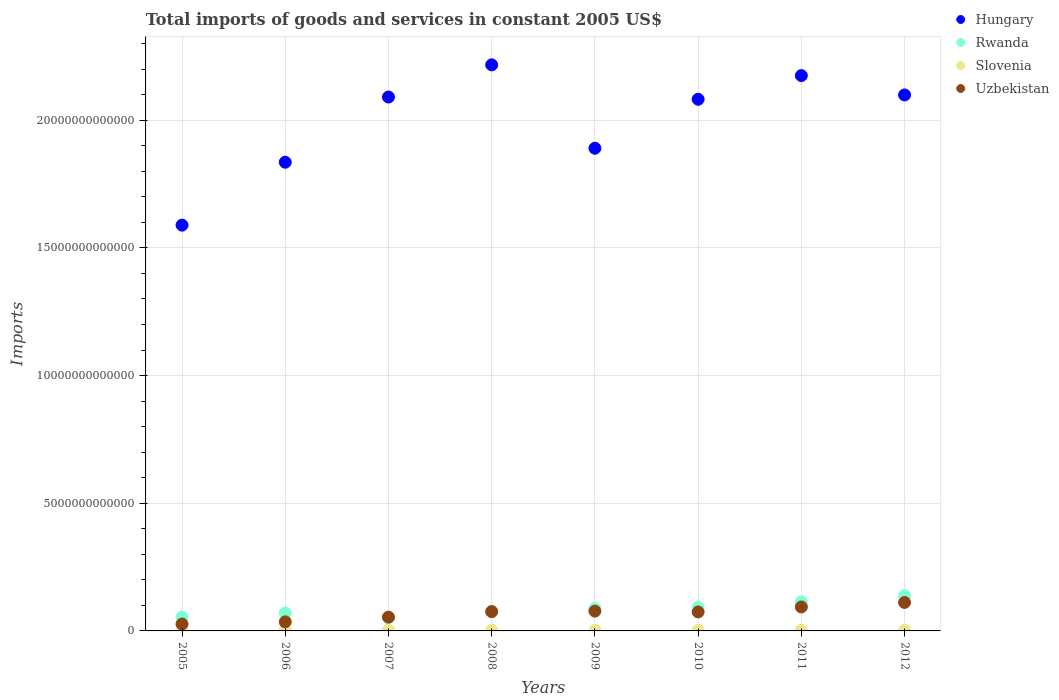What is the total imports of goods and services in Slovenia in 2006?
Give a very brief answer. 2.17e+1. Across all years, what is the maximum total imports of goods and services in Slovenia?
Your response must be concise. 2.63e+1. Across all years, what is the minimum total imports of goods and services in Rwanda?
Provide a short and direct response. 5.21e+11. In which year was the total imports of goods and services in Slovenia maximum?
Ensure brevity in your answer.  2008. In which year was the total imports of goods and services in Rwanda minimum?
Provide a short and direct response. 2007. What is the total total imports of goods and services in Slovenia in the graph?
Make the answer very short. 1.84e+11. What is the difference between the total imports of goods and services in Hungary in 2007 and that in 2011?
Your response must be concise. -8.39e+11. What is the difference between the total imports of goods and services in Hungary in 2006 and the total imports of goods and services in Rwanda in 2012?
Your answer should be very brief. 1.70e+13. What is the average total imports of goods and services in Rwanda per year?
Your answer should be very brief. 8.57e+11. In the year 2008, what is the difference between the total imports of goods and services in Hungary and total imports of goods and services in Slovenia?
Keep it short and to the point. 2.21e+13. What is the ratio of the total imports of goods and services in Hungary in 2009 to that in 2011?
Your response must be concise. 0.87. Is the total imports of goods and services in Uzbekistan in 2005 less than that in 2011?
Keep it short and to the point. Yes. What is the difference between the highest and the second highest total imports of goods and services in Rwanda?
Provide a succinct answer. 2.43e+11. What is the difference between the highest and the lowest total imports of goods and services in Rwanda?
Offer a terse response. 8.61e+11. In how many years, is the total imports of goods and services in Slovenia greater than the average total imports of goods and services in Slovenia taken over all years?
Provide a succinct answer. 4. Is the sum of the total imports of goods and services in Rwanda in 2006 and 2009 greater than the maximum total imports of goods and services in Hungary across all years?
Provide a succinct answer. No. Does the total imports of goods and services in Hungary monotonically increase over the years?
Provide a short and direct response. No. How many dotlines are there?
Offer a terse response. 4. What is the difference between two consecutive major ticks on the Y-axis?
Your answer should be compact. 5.00e+12. Where does the legend appear in the graph?
Your response must be concise. Top right. What is the title of the graph?
Ensure brevity in your answer.  Total imports of goods and services in constant 2005 US$. What is the label or title of the Y-axis?
Provide a succinct answer. Imports. What is the Imports in Hungary in 2005?
Give a very brief answer. 1.59e+13. What is the Imports of Rwanda in 2005?
Offer a very short reply. 5.43e+11. What is the Imports in Slovenia in 2005?
Your response must be concise. 1.93e+1. What is the Imports in Uzbekistan in 2005?
Ensure brevity in your answer.  2.72e+11. What is the Imports of Hungary in 2006?
Keep it short and to the point. 1.84e+13. What is the Imports of Rwanda in 2006?
Your answer should be compact. 7.03e+11. What is the Imports in Slovenia in 2006?
Provide a succinct answer. 2.17e+1. What is the Imports in Uzbekistan in 2006?
Offer a terse response. 3.55e+11. What is the Imports in Hungary in 2007?
Keep it short and to the point. 2.09e+13. What is the Imports of Rwanda in 2007?
Offer a terse response. 5.21e+11. What is the Imports in Slovenia in 2007?
Keep it short and to the point. 2.53e+1. What is the Imports in Uzbekistan in 2007?
Your response must be concise. 5.40e+11. What is the Imports in Hungary in 2008?
Provide a short and direct response. 2.22e+13. What is the Imports in Rwanda in 2008?
Provide a succinct answer. 7.78e+11. What is the Imports in Slovenia in 2008?
Keep it short and to the point. 2.63e+1. What is the Imports in Uzbekistan in 2008?
Your response must be concise. 7.55e+11. What is the Imports of Hungary in 2009?
Your response must be concise. 1.89e+13. What is the Imports in Rwanda in 2009?
Your answer should be compact. 8.77e+11. What is the Imports in Slovenia in 2009?
Provide a succinct answer. 2.13e+1. What is the Imports in Uzbekistan in 2009?
Your answer should be very brief. 7.75e+11. What is the Imports of Hungary in 2010?
Ensure brevity in your answer.  2.08e+13. What is the Imports of Rwanda in 2010?
Offer a terse response. 9.15e+11. What is the Imports of Slovenia in 2010?
Your answer should be very brief. 2.28e+1. What is the Imports in Uzbekistan in 2010?
Provide a short and direct response. 7.43e+11. What is the Imports of Hungary in 2011?
Offer a terse response. 2.17e+13. What is the Imports of Rwanda in 2011?
Your response must be concise. 1.14e+12. What is the Imports of Slovenia in 2011?
Provide a succinct answer. 2.39e+1. What is the Imports of Uzbekistan in 2011?
Give a very brief answer. 9.39e+11. What is the Imports of Hungary in 2012?
Make the answer very short. 2.10e+13. What is the Imports in Rwanda in 2012?
Your answer should be very brief. 1.38e+12. What is the Imports in Slovenia in 2012?
Your response must be concise. 2.30e+1. What is the Imports of Uzbekistan in 2012?
Your answer should be very brief. 1.12e+12. Across all years, what is the maximum Imports of Hungary?
Make the answer very short. 2.22e+13. Across all years, what is the maximum Imports of Rwanda?
Your answer should be compact. 1.38e+12. Across all years, what is the maximum Imports in Slovenia?
Your answer should be very brief. 2.63e+1. Across all years, what is the maximum Imports of Uzbekistan?
Make the answer very short. 1.12e+12. Across all years, what is the minimum Imports of Hungary?
Offer a terse response. 1.59e+13. Across all years, what is the minimum Imports of Rwanda?
Make the answer very short. 5.21e+11. Across all years, what is the minimum Imports in Slovenia?
Your response must be concise. 1.93e+1. Across all years, what is the minimum Imports in Uzbekistan?
Offer a terse response. 2.72e+11. What is the total Imports of Hungary in the graph?
Your response must be concise. 1.60e+14. What is the total Imports in Rwanda in the graph?
Your answer should be compact. 6.86e+12. What is the total Imports of Slovenia in the graph?
Make the answer very short. 1.84e+11. What is the total Imports of Uzbekistan in the graph?
Provide a short and direct response. 5.49e+12. What is the difference between the Imports of Hungary in 2005 and that in 2006?
Offer a terse response. -2.46e+12. What is the difference between the Imports in Rwanda in 2005 and that in 2006?
Offer a very short reply. -1.60e+11. What is the difference between the Imports of Slovenia in 2005 and that in 2006?
Offer a very short reply. -2.39e+09. What is the difference between the Imports in Uzbekistan in 2005 and that in 2006?
Ensure brevity in your answer.  -8.37e+1. What is the difference between the Imports in Hungary in 2005 and that in 2007?
Your answer should be compact. -5.02e+12. What is the difference between the Imports of Rwanda in 2005 and that in 2007?
Offer a very short reply. 2.20e+1. What is the difference between the Imports in Slovenia in 2005 and that in 2007?
Provide a short and direct response. -6.02e+09. What is the difference between the Imports in Uzbekistan in 2005 and that in 2007?
Ensure brevity in your answer.  -2.68e+11. What is the difference between the Imports of Hungary in 2005 and that in 2008?
Your response must be concise. -6.28e+12. What is the difference between the Imports in Rwanda in 2005 and that in 2008?
Provide a succinct answer. -2.35e+11. What is the difference between the Imports in Slovenia in 2005 and that in 2008?
Offer a very short reply. -7.00e+09. What is the difference between the Imports of Uzbekistan in 2005 and that in 2008?
Offer a terse response. -4.83e+11. What is the difference between the Imports in Hungary in 2005 and that in 2009?
Ensure brevity in your answer.  -3.01e+12. What is the difference between the Imports of Rwanda in 2005 and that in 2009?
Ensure brevity in your answer.  -3.34e+11. What is the difference between the Imports in Slovenia in 2005 and that in 2009?
Make the answer very short. -2.04e+09. What is the difference between the Imports of Uzbekistan in 2005 and that in 2009?
Offer a terse response. -5.03e+11. What is the difference between the Imports in Hungary in 2005 and that in 2010?
Give a very brief answer. -4.93e+12. What is the difference between the Imports of Rwanda in 2005 and that in 2010?
Offer a terse response. -3.72e+11. What is the difference between the Imports in Slovenia in 2005 and that in 2010?
Keep it short and to the point. -3.50e+09. What is the difference between the Imports in Uzbekistan in 2005 and that in 2010?
Give a very brief answer. -4.71e+11. What is the difference between the Imports in Hungary in 2005 and that in 2011?
Provide a succinct answer. -5.86e+12. What is the difference between the Imports of Rwanda in 2005 and that in 2011?
Offer a terse response. -5.96e+11. What is the difference between the Imports of Slovenia in 2005 and that in 2011?
Your answer should be compact. -4.64e+09. What is the difference between the Imports of Uzbekistan in 2005 and that in 2011?
Provide a short and direct response. -6.67e+11. What is the difference between the Imports in Hungary in 2005 and that in 2012?
Keep it short and to the point. -5.10e+12. What is the difference between the Imports of Rwanda in 2005 and that in 2012?
Provide a succinct answer. -8.39e+11. What is the difference between the Imports in Slovenia in 2005 and that in 2012?
Keep it short and to the point. -3.75e+09. What is the difference between the Imports of Uzbekistan in 2005 and that in 2012?
Ensure brevity in your answer.  -8.44e+11. What is the difference between the Imports in Hungary in 2006 and that in 2007?
Your answer should be very brief. -2.55e+12. What is the difference between the Imports of Rwanda in 2006 and that in 2007?
Keep it short and to the point. 1.82e+11. What is the difference between the Imports in Slovenia in 2006 and that in 2007?
Make the answer very short. -3.63e+09. What is the difference between the Imports in Uzbekistan in 2006 and that in 2007?
Make the answer very short. -1.85e+11. What is the difference between the Imports in Hungary in 2006 and that in 2008?
Provide a succinct answer. -3.81e+12. What is the difference between the Imports of Rwanda in 2006 and that in 2008?
Give a very brief answer. -7.50e+1. What is the difference between the Imports of Slovenia in 2006 and that in 2008?
Ensure brevity in your answer.  -4.61e+09. What is the difference between the Imports of Uzbekistan in 2006 and that in 2008?
Offer a very short reply. -3.99e+11. What is the difference between the Imports in Hungary in 2006 and that in 2009?
Your answer should be very brief. -5.47e+11. What is the difference between the Imports in Rwanda in 2006 and that in 2009?
Provide a succinct answer. -1.74e+11. What is the difference between the Imports of Slovenia in 2006 and that in 2009?
Provide a succinct answer. 3.45e+08. What is the difference between the Imports in Uzbekistan in 2006 and that in 2009?
Give a very brief answer. -4.20e+11. What is the difference between the Imports in Hungary in 2006 and that in 2010?
Ensure brevity in your answer.  -2.46e+12. What is the difference between the Imports of Rwanda in 2006 and that in 2010?
Make the answer very short. -2.12e+11. What is the difference between the Imports in Slovenia in 2006 and that in 2010?
Ensure brevity in your answer.  -1.11e+09. What is the difference between the Imports in Uzbekistan in 2006 and that in 2010?
Your response must be concise. -3.88e+11. What is the difference between the Imports in Hungary in 2006 and that in 2011?
Offer a terse response. -3.39e+12. What is the difference between the Imports of Rwanda in 2006 and that in 2011?
Ensure brevity in your answer.  -4.36e+11. What is the difference between the Imports in Slovenia in 2006 and that in 2011?
Your answer should be very brief. -2.25e+09. What is the difference between the Imports in Uzbekistan in 2006 and that in 2011?
Your response must be concise. -5.83e+11. What is the difference between the Imports in Hungary in 2006 and that in 2012?
Offer a very short reply. -2.63e+12. What is the difference between the Imports in Rwanda in 2006 and that in 2012?
Provide a succinct answer. -6.79e+11. What is the difference between the Imports of Slovenia in 2006 and that in 2012?
Make the answer very short. -1.37e+09. What is the difference between the Imports in Uzbekistan in 2006 and that in 2012?
Your response must be concise. -7.60e+11. What is the difference between the Imports in Hungary in 2007 and that in 2008?
Your answer should be very brief. -1.26e+12. What is the difference between the Imports of Rwanda in 2007 and that in 2008?
Provide a short and direct response. -2.57e+11. What is the difference between the Imports in Slovenia in 2007 and that in 2008?
Make the answer very short. -9.74e+08. What is the difference between the Imports in Uzbekistan in 2007 and that in 2008?
Your answer should be very brief. -2.15e+11. What is the difference between the Imports in Hungary in 2007 and that in 2009?
Provide a succinct answer. 2.01e+12. What is the difference between the Imports of Rwanda in 2007 and that in 2009?
Ensure brevity in your answer.  -3.56e+11. What is the difference between the Imports in Slovenia in 2007 and that in 2009?
Ensure brevity in your answer.  3.98e+09. What is the difference between the Imports in Uzbekistan in 2007 and that in 2009?
Your answer should be very brief. -2.35e+11. What is the difference between the Imports in Hungary in 2007 and that in 2010?
Provide a short and direct response. 8.74e+1. What is the difference between the Imports of Rwanda in 2007 and that in 2010?
Provide a short and direct response. -3.94e+11. What is the difference between the Imports in Slovenia in 2007 and that in 2010?
Ensure brevity in your answer.  2.52e+09. What is the difference between the Imports in Uzbekistan in 2007 and that in 2010?
Offer a terse response. -2.03e+11. What is the difference between the Imports in Hungary in 2007 and that in 2011?
Your answer should be very brief. -8.39e+11. What is the difference between the Imports in Rwanda in 2007 and that in 2011?
Provide a short and direct response. -6.18e+11. What is the difference between the Imports of Slovenia in 2007 and that in 2011?
Your response must be concise. 1.38e+09. What is the difference between the Imports of Uzbekistan in 2007 and that in 2011?
Provide a short and direct response. -3.99e+11. What is the difference between the Imports in Hungary in 2007 and that in 2012?
Your response must be concise. -8.21e+1. What is the difference between the Imports of Rwanda in 2007 and that in 2012?
Keep it short and to the point. -8.61e+11. What is the difference between the Imports in Slovenia in 2007 and that in 2012?
Offer a very short reply. 2.27e+09. What is the difference between the Imports in Uzbekistan in 2007 and that in 2012?
Make the answer very short. -5.75e+11. What is the difference between the Imports in Hungary in 2008 and that in 2009?
Offer a very short reply. 3.27e+12. What is the difference between the Imports in Rwanda in 2008 and that in 2009?
Give a very brief answer. -9.90e+1. What is the difference between the Imports in Slovenia in 2008 and that in 2009?
Provide a short and direct response. 4.95e+09. What is the difference between the Imports in Uzbekistan in 2008 and that in 2009?
Your answer should be very brief. -2.02e+1. What is the difference between the Imports in Hungary in 2008 and that in 2010?
Your response must be concise. 1.35e+12. What is the difference between the Imports in Rwanda in 2008 and that in 2010?
Offer a terse response. -1.37e+11. What is the difference between the Imports in Slovenia in 2008 and that in 2010?
Provide a short and direct response. 3.49e+09. What is the difference between the Imports of Uzbekistan in 2008 and that in 2010?
Keep it short and to the point. 1.18e+1. What is the difference between the Imports in Hungary in 2008 and that in 2011?
Give a very brief answer. 4.21e+11. What is the difference between the Imports of Rwanda in 2008 and that in 2011?
Your answer should be compact. -3.61e+11. What is the difference between the Imports in Slovenia in 2008 and that in 2011?
Give a very brief answer. 2.35e+09. What is the difference between the Imports of Uzbekistan in 2008 and that in 2011?
Provide a short and direct response. -1.84e+11. What is the difference between the Imports of Hungary in 2008 and that in 2012?
Your answer should be compact. 1.18e+12. What is the difference between the Imports of Rwanda in 2008 and that in 2012?
Give a very brief answer. -6.04e+11. What is the difference between the Imports of Slovenia in 2008 and that in 2012?
Offer a very short reply. 3.24e+09. What is the difference between the Imports of Uzbekistan in 2008 and that in 2012?
Ensure brevity in your answer.  -3.60e+11. What is the difference between the Imports of Hungary in 2009 and that in 2010?
Your answer should be very brief. -1.92e+12. What is the difference between the Imports in Rwanda in 2009 and that in 2010?
Offer a terse response. -3.80e+1. What is the difference between the Imports of Slovenia in 2009 and that in 2010?
Provide a short and direct response. -1.46e+09. What is the difference between the Imports of Uzbekistan in 2009 and that in 2010?
Give a very brief answer. 3.20e+1. What is the difference between the Imports in Hungary in 2009 and that in 2011?
Provide a short and direct response. -2.84e+12. What is the difference between the Imports of Rwanda in 2009 and that in 2011?
Make the answer very short. -2.62e+11. What is the difference between the Imports of Slovenia in 2009 and that in 2011?
Offer a terse response. -2.60e+09. What is the difference between the Imports of Uzbekistan in 2009 and that in 2011?
Offer a terse response. -1.64e+11. What is the difference between the Imports of Hungary in 2009 and that in 2012?
Make the answer very short. -2.09e+12. What is the difference between the Imports of Rwanda in 2009 and that in 2012?
Ensure brevity in your answer.  -5.05e+11. What is the difference between the Imports in Slovenia in 2009 and that in 2012?
Ensure brevity in your answer.  -1.71e+09. What is the difference between the Imports of Uzbekistan in 2009 and that in 2012?
Offer a terse response. -3.40e+11. What is the difference between the Imports of Hungary in 2010 and that in 2011?
Keep it short and to the point. -9.27e+11. What is the difference between the Imports in Rwanda in 2010 and that in 2011?
Keep it short and to the point. -2.24e+11. What is the difference between the Imports in Slovenia in 2010 and that in 2011?
Provide a short and direct response. -1.14e+09. What is the difference between the Imports of Uzbekistan in 2010 and that in 2011?
Offer a terse response. -1.96e+11. What is the difference between the Imports in Hungary in 2010 and that in 2012?
Offer a very short reply. -1.69e+11. What is the difference between the Imports in Rwanda in 2010 and that in 2012?
Offer a very short reply. -4.67e+11. What is the difference between the Imports of Slovenia in 2010 and that in 2012?
Give a very brief answer. -2.52e+08. What is the difference between the Imports of Uzbekistan in 2010 and that in 2012?
Your response must be concise. -3.72e+11. What is the difference between the Imports of Hungary in 2011 and that in 2012?
Your answer should be very brief. 7.57e+11. What is the difference between the Imports in Rwanda in 2011 and that in 2012?
Ensure brevity in your answer.  -2.43e+11. What is the difference between the Imports of Slovenia in 2011 and that in 2012?
Give a very brief answer. 8.86e+08. What is the difference between the Imports of Uzbekistan in 2011 and that in 2012?
Give a very brief answer. -1.77e+11. What is the difference between the Imports in Hungary in 2005 and the Imports in Rwanda in 2006?
Offer a very short reply. 1.52e+13. What is the difference between the Imports of Hungary in 2005 and the Imports of Slovenia in 2006?
Your response must be concise. 1.59e+13. What is the difference between the Imports of Hungary in 2005 and the Imports of Uzbekistan in 2006?
Provide a short and direct response. 1.55e+13. What is the difference between the Imports in Rwanda in 2005 and the Imports in Slovenia in 2006?
Provide a succinct answer. 5.21e+11. What is the difference between the Imports in Rwanda in 2005 and the Imports in Uzbekistan in 2006?
Provide a succinct answer. 1.88e+11. What is the difference between the Imports in Slovenia in 2005 and the Imports in Uzbekistan in 2006?
Ensure brevity in your answer.  -3.36e+11. What is the difference between the Imports in Hungary in 2005 and the Imports in Rwanda in 2007?
Keep it short and to the point. 1.54e+13. What is the difference between the Imports of Hungary in 2005 and the Imports of Slovenia in 2007?
Make the answer very short. 1.59e+13. What is the difference between the Imports of Hungary in 2005 and the Imports of Uzbekistan in 2007?
Make the answer very short. 1.53e+13. What is the difference between the Imports in Rwanda in 2005 and the Imports in Slovenia in 2007?
Give a very brief answer. 5.18e+11. What is the difference between the Imports of Rwanda in 2005 and the Imports of Uzbekistan in 2007?
Your response must be concise. 3.06e+09. What is the difference between the Imports in Slovenia in 2005 and the Imports in Uzbekistan in 2007?
Offer a terse response. -5.21e+11. What is the difference between the Imports of Hungary in 2005 and the Imports of Rwanda in 2008?
Offer a very short reply. 1.51e+13. What is the difference between the Imports of Hungary in 2005 and the Imports of Slovenia in 2008?
Offer a very short reply. 1.59e+13. What is the difference between the Imports in Hungary in 2005 and the Imports in Uzbekistan in 2008?
Provide a succinct answer. 1.51e+13. What is the difference between the Imports of Rwanda in 2005 and the Imports of Slovenia in 2008?
Your answer should be compact. 5.17e+11. What is the difference between the Imports in Rwanda in 2005 and the Imports in Uzbekistan in 2008?
Keep it short and to the point. -2.12e+11. What is the difference between the Imports in Slovenia in 2005 and the Imports in Uzbekistan in 2008?
Provide a short and direct response. -7.36e+11. What is the difference between the Imports of Hungary in 2005 and the Imports of Rwanda in 2009?
Your response must be concise. 1.50e+13. What is the difference between the Imports of Hungary in 2005 and the Imports of Slovenia in 2009?
Your answer should be compact. 1.59e+13. What is the difference between the Imports in Hungary in 2005 and the Imports in Uzbekistan in 2009?
Your response must be concise. 1.51e+13. What is the difference between the Imports of Rwanda in 2005 and the Imports of Slovenia in 2009?
Provide a short and direct response. 5.22e+11. What is the difference between the Imports in Rwanda in 2005 and the Imports in Uzbekistan in 2009?
Ensure brevity in your answer.  -2.32e+11. What is the difference between the Imports in Slovenia in 2005 and the Imports in Uzbekistan in 2009?
Make the answer very short. -7.56e+11. What is the difference between the Imports of Hungary in 2005 and the Imports of Rwanda in 2010?
Offer a terse response. 1.50e+13. What is the difference between the Imports in Hungary in 2005 and the Imports in Slovenia in 2010?
Make the answer very short. 1.59e+13. What is the difference between the Imports of Hungary in 2005 and the Imports of Uzbekistan in 2010?
Give a very brief answer. 1.51e+13. What is the difference between the Imports in Rwanda in 2005 and the Imports in Slovenia in 2010?
Give a very brief answer. 5.20e+11. What is the difference between the Imports in Rwanda in 2005 and the Imports in Uzbekistan in 2010?
Provide a short and direct response. -2.00e+11. What is the difference between the Imports of Slovenia in 2005 and the Imports of Uzbekistan in 2010?
Offer a very short reply. -7.24e+11. What is the difference between the Imports in Hungary in 2005 and the Imports in Rwanda in 2011?
Your response must be concise. 1.48e+13. What is the difference between the Imports in Hungary in 2005 and the Imports in Slovenia in 2011?
Keep it short and to the point. 1.59e+13. What is the difference between the Imports of Hungary in 2005 and the Imports of Uzbekistan in 2011?
Give a very brief answer. 1.50e+13. What is the difference between the Imports of Rwanda in 2005 and the Imports of Slovenia in 2011?
Provide a succinct answer. 5.19e+11. What is the difference between the Imports in Rwanda in 2005 and the Imports in Uzbekistan in 2011?
Make the answer very short. -3.96e+11. What is the difference between the Imports in Slovenia in 2005 and the Imports in Uzbekistan in 2011?
Your answer should be very brief. -9.19e+11. What is the difference between the Imports of Hungary in 2005 and the Imports of Rwanda in 2012?
Give a very brief answer. 1.45e+13. What is the difference between the Imports of Hungary in 2005 and the Imports of Slovenia in 2012?
Keep it short and to the point. 1.59e+13. What is the difference between the Imports of Hungary in 2005 and the Imports of Uzbekistan in 2012?
Keep it short and to the point. 1.48e+13. What is the difference between the Imports of Rwanda in 2005 and the Imports of Slovenia in 2012?
Make the answer very short. 5.20e+11. What is the difference between the Imports of Rwanda in 2005 and the Imports of Uzbekistan in 2012?
Provide a short and direct response. -5.72e+11. What is the difference between the Imports in Slovenia in 2005 and the Imports in Uzbekistan in 2012?
Give a very brief answer. -1.10e+12. What is the difference between the Imports of Hungary in 2006 and the Imports of Rwanda in 2007?
Your answer should be very brief. 1.78e+13. What is the difference between the Imports of Hungary in 2006 and the Imports of Slovenia in 2007?
Provide a succinct answer. 1.83e+13. What is the difference between the Imports of Hungary in 2006 and the Imports of Uzbekistan in 2007?
Provide a short and direct response. 1.78e+13. What is the difference between the Imports of Rwanda in 2006 and the Imports of Slovenia in 2007?
Make the answer very short. 6.78e+11. What is the difference between the Imports of Rwanda in 2006 and the Imports of Uzbekistan in 2007?
Give a very brief answer. 1.63e+11. What is the difference between the Imports of Slovenia in 2006 and the Imports of Uzbekistan in 2007?
Your answer should be compact. -5.18e+11. What is the difference between the Imports in Hungary in 2006 and the Imports in Rwanda in 2008?
Provide a short and direct response. 1.76e+13. What is the difference between the Imports of Hungary in 2006 and the Imports of Slovenia in 2008?
Offer a terse response. 1.83e+13. What is the difference between the Imports in Hungary in 2006 and the Imports in Uzbekistan in 2008?
Give a very brief answer. 1.76e+13. What is the difference between the Imports in Rwanda in 2006 and the Imports in Slovenia in 2008?
Make the answer very short. 6.77e+11. What is the difference between the Imports of Rwanda in 2006 and the Imports of Uzbekistan in 2008?
Ensure brevity in your answer.  -5.18e+1. What is the difference between the Imports in Slovenia in 2006 and the Imports in Uzbekistan in 2008?
Offer a very short reply. -7.33e+11. What is the difference between the Imports of Hungary in 2006 and the Imports of Rwanda in 2009?
Your answer should be compact. 1.75e+13. What is the difference between the Imports in Hungary in 2006 and the Imports in Slovenia in 2009?
Your answer should be compact. 1.83e+13. What is the difference between the Imports in Hungary in 2006 and the Imports in Uzbekistan in 2009?
Ensure brevity in your answer.  1.76e+13. What is the difference between the Imports of Rwanda in 2006 and the Imports of Slovenia in 2009?
Your response must be concise. 6.82e+11. What is the difference between the Imports of Rwanda in 2006 and the Imports of Uzbekistan in 2009?
Your response must be concise. -7.20e+1. What is the difference between the Imports in Slovenia in 2006 and the Imports in Uzbekistan in 2009?
Your response must be concise. -7.53e+11. What is the difference between the Imports of Hungary in 2006 and the Imports of Rwanda in 2010?
Your answer should be very brief. 1.74e+13. What is the difference between the Imports of Hungary in 2006 and the Imports of Slovenia in 2010?
Your answer should be very brief. 1.83e+13. What is the difference between the Imports of Hungary in 2006 and the Imports of Uzbekistan in 2010?
Ensure brevity in your answer.  1.76e+13. What is the difference between the Imports of Rwanda in 2006 and the Imports of Slovenia in 2010?
Provide a succinct answer. 6.80e+11. What is the difference between the Imports of Rwanda in 2006 and the Imports of Uzbekistan in 2010?
Offer a very short reply. -4.00e+1. What is the difference between the Imports in Slovenia in 2006 and the Imports in Uzbekistan in 2010?
Offer a very short reply. -7.21e+11. What is the difference between the Imports in Hungary in 2006 and the Imports in Rwanda in 2011?
Your answer should be compact. 1.72e+13. What is the difference between the Imports in Hungary in 2006 and the Imports in Slovenia in 2011?
Your answer should be compact. 1.83e+13. What is the difference between the Imports of Hungary in 2006 and the Imports of Uzbekistan in 2011?
Your answer should be compact. 1.74e+13. What is the difference between the Imports of Rwanda in 2006 and the Imports of Slovenia in 2011?
Your answer should be compact. 6.79e+11. What is the difference between the Imports of Rwanda in 2006 and the Imports of Uzbekistan in 2011?
Your response must be concise. -2.36e+11. What is the difference between the Imports in Slovenia in 2006 and the Imports in Uzbekistan in 2011?
Your response must be concise. -9.17e+11. What is the difference between the Imports in Hungary in 2006 and the Imports in Rwanda in 2012?
Keep it short and to the point. 1.70e+13. What is the difference between the Imports in Hungary in 2006 and the Imports in Slovenia in 2012?
Your answer should be compact. 1.83e+13. What is the difference between the Imports in Hungary in 2006 and the Imports in Uzbekistan in 2012?
Provide a succinct answer. 1.72e+13. What is the difference between the Imports of Rwanda in 2006 and the Imports of Slovenia in 2012?
Give a very brief answer. 6.80e+11. What is the difference between the Imports of Rwanda in 2006 and the Imports of Uzbekistan in 2012?
Offer a very short reply. -4.12e+11. What is the difference between the Imports of Slovenia in 2006 and the Imports of Uzbekistan in 2012?
Keep it short and to the point. -1.09e+12. What is the difference between the Imports in Hungary in 2007 and the Imports in Rwanda in 2008?
Your answer should be very brief. 2.01e+13. What is the difference between the Imports of Hungary in 2007 and the Imports of Slovenia in 2008?
Provide a succinct answer. 2.09e+13. What is the difference between the Imports of Hungary in 2007 and the Imports of Uzbekistan in 2008?
Make the answer very short. 2.02e+13. What is the difference between the Imports of Rwanda in 2007 and the Imports of Slovenia in 2008?
Give a very brief answer. 4.95e+11. What is the difference between the Imports of Rwanda in 2007 and the Imports of Uzbekistan in 2008?
Offer a very short reply. -2.34e+11. What is the difference between the Imports in Slovenia in 2007 and the Imports in Uzbekistan in 2008?
Your answer should be very brief. -7.29e+11. What is the difference between the Imports of Hungary in 2007 and the Imports of Rwanda in 2009?
Offer a very short reply. 2.00e+13. What is the difference between the Imports in Hungary in 2007 and the Imports in Slovenia in 2009?
Keep it short and to the point. 2.09e+13. What is the difference between the Imports in Hungary in 2007 and the Imports in Uzbekistan in 2009?
Keep it short and to the point. 2.01e+13. What is the difference between the Imports of Rwanda in 2007 and the Imports of Slovenia in 2009?
Provide a succinct answer. 5.00e+11. What is the difference between the Imports of Rwanda in 2007 and the Imports of Uzbekistan in 2009?
Your response must be concise. -2.54e+11. What is the difference between the Imports of Slovenia in 2007 and the Imports of Uzbekistan in 2009?
Keep it short and to the point. -7.50e+11. What is the difference between the Imports in Hungary in 2007 and the Imports in Rwanda in 2010?
Ensure brevity in your answer.  2.00e+13. What is the difference between the Imports in Hungary in 2007 and the Imports in Slovenia in 2010?
Provide a short and direct response. 2.09e+13. What is the difference between the Imports of Hungary in 2007 and the Imports of Uzbekistan in 2010?
Provide a succinct answer. 2.02e+13. What is the difference between the Imports of Rwanda in 2007 and the Imports of Slovenia in 2010?
Keep it short and to the point. 4.98e+11. What is the difference between the Imports of Rwanda in 2007 and the Imports of Uzbekistan in 2010?
Your answer should be compact. -2.22e+11. What is the difference between the Imports of Slovenia in 2007 and the Imports of Uzbekistan in 2010?
Your answer should be compact. -7.18e+11. What is the difference between the Imports of Hungary in 2007 and the Imports of Rwanda in 2011?
Give a very brief answer. 1.98e+13. What is the difference between the Imports of Hungary in 2007 and the Imports of Slovenia in 2011?
Your answer should be compact. 2.09e+13. What is the difference between the Imports of Hungary in 2007 and the Imports of Uzbekistan in 2011?
Your answer should be compact. 2.00e+13. What is the difference between the Imports of Rwanda in 2007 and the Imports of Slovenia in 2011?
Ensure brevity in your answer.  4.97e+11. What is the difference between the Imports in Rwanda in 2007 and the Imports in Uzbekistan in 2011?
Your answer should be very brief. -4.18e+11. What is the difference between the Imports of Slovenia in 2007 and the Imports of Uzbekistan in 2011?
Offer a very short reply. -9.13e+11. What is the difference between the Imports of Hungary in 2007 and the Imports of Rwanda in 2012?
Ensure brevity in your answer.  1.95e+13. What is the difference between the Imports of Hungary in 2007 and the Imports of Slovenia in 2012?
Your answer should be very brief. 2.09e+13. What is the difference between the Imports in Hungary in 2007 and the Imports in Uzbekistan in 2012?
Provide a short and direct response. 1.98e+13. What is the difference between the Imports of Rwanda in 2007 and the Imports of Slovenia in 2012?
Provide a short and direct response. 4.98e+11. What is the difference between the Imports of Rwanda in 2007 and the Imports of Uzbekistan in 2012?
Your answer should be compact. -5.94e+11. What is the difference between the Imports of Slovenia in 2007 and the Imports of Uzbekistan in 2012?
Ensure brevity in your answer.  -1.09e+12. What is the difference between the Imports in Hungary in 2008 and the Imports in Rwanda in 2009?
Your answer should be compact. 2.13e+13. What is the difference between the Imports of Hungary in 2008 and the Imports of Slovenia in 2009?
Offer a very short reply. 2.21e+13. What is the difference between the Imports of Hungary in 2008 and the Imports of Uzbekistan in 2009?
Provide a succinct answer. 2.14e+13. What is the difference between the Imports of Rwanda in 2008 and the Imports of Slovenia in 2009?
Your answer should be very brief. 7.57e+11. What is the difference between the Imports of Rwanda in 2008 and the Imports of Uzbekistan in 2009?
Provide a succinct answer. 3.01e+09. What is the difference between the Imports of Slovenia in 2008 and the Imports of Uzbekistan in 2009?
Your response must be concise. -7.49e+11. What is the difference between the Imports in Hungary in 2008 and the Imports in Rwanda in 2010?
Provide a succinct answer. 2.13e+13. What is the difference between the Imports of Hungary in 2008 and the Imports of Slovenia in 2010?
Give a very brief answer. 2.21e+13. What is the difference between the Imports of Hungary in 2008 and the Imports of Uzbekistan in 2010?
Make the answer very short. 2.14e+13. What is the difference between the Imports of Rwanda in 2008 and the Imports of Slovenia in 2010?
Keep it short and to the point. 7.55e+11. What is the difference between the Imports in Rwanda in 2008 and the Imports in Uzbekistan in 2010?
Offer a very short reply. 3.50e+1. What is the difference between the Imports of Slovenia in 2008 and the Imports of Uzbekistan in 2010?
Offer a terse response. -7.17e+11. What is the difference between the Imports in Hungary in 2008 and the Imports in Rwanda in 2011?
Your answer should be very brief. 2.10e+13. What is the difference between the Imports of Hungary in 2008 and the Imports of Slovenia in 2011?
Make the answer very short. 2.21e+13. What is the difference between the Imports of Hungary in 2008 and the Imports of Uzbekistan in 2011?
Offer a terse response. 2.12e+13. What is the difference between the Imports of Rwanda in 2008 and the Imports of Slovenia in 2011?
Your answer should be very brief. 7.54e+11. What is the difference between the Imports in Rwanda in 2008 and the Imports in Uzbekistan in 2011?
Your answer should be very brief. -1.61e+11. What is the difference between the Imports of Slovenia in 2008 and the Imports of Uzbekistan in 2011?
Make the answer very short. -9.12e+11. What is the difference between the Imports in Hungary in 2008 and the Imports in Rwanda in 2012?
Offer a very short reply. 2.08e+13. What is the difference between the Imports in Hungary in 2008 and the Imports in Slovenia in 2012?
Offer a very short reply. 2.21e+13. What is the difference between the Imports of Hungary in 2008 and the Imports of Uzbekistan in 2012?
Provide a succinct answer. 2.11e+13. What is the difference between the Imports of Rwanda in 2008 and the Imports of Slovenia in 2012?
Offer a very short reply. 7.55e+11. What is the difference between the Imports in Rwanda in 2008 and the Imports in Uzbekistan in 2012?
Provide a succinct answer. -3.37e+11. What is the difference between the Imports in Slovenia in 2008 and the Imports in Uzbekistan in 2012?
Your response must be concise. -1.09e+12. What is the difference between the Imports in Hungary in 2009 and the Imports in Rwanda in 2010?
Offer a terse response. 1.80e+13. What is the difference between the Imports of Hungary in 2009 and the Imports of Slovenia in 2010?
Your answer should be compact. 1.89e+13. What is the difference between the Imports of Hungary in 2009 and the Imports of Uzbekistan in 2010?
Your response must be concise. 1.82e+13. What is the difference between the Imports of Rwanda in 2009 and the Imports of Slovenia in 2010?
Provide a short and direct response. 8.54e+11. What is the difference between the Imports of Rwanda in 2009 and the Imports of Uzbekistan in 2010?
Your response must be concise. 1.34e+11. What is the difference between the Imports of Slovenia in 2009 and the Imports of Uzbekistan in 2010?
Give a very brief answer. -7.22e+11. What is the difference between the Imports in Hungary in 2009 and the Imports in Rwanda in 2011?
Offer a terse response. 1.78e+13. What is the difference between the Imports in Hungary in 2009 and the Imports in Slovenia in 2011?
Offer a very short reply. 1.89e+13. What is the difference between the Imports of Hungary in 2009 and the Imports of Uzbekistan in 2011?
Make the answer very short. 1.80e+13. What is the difference between the Imports in Rwanda in 2009 and the Imports in Slovenia in 2011?
Ensure brevity in your answer.  8.53e+11. What is the difference between the Imports in Rwanda in 2009 and the Imports in Uzbekistan in 2011?
Ensure brevity in your answer.  -6.16e+1. What is the difference between the Imports of Slovenia in 2009 and the Imports of Uzbekistan in 2011?
Provide a short and direct response. -9.17e+11. What is the difference between the Imports in Hungary in 2009 and the Imports in Rwanda in 2012?
Your response must be concise. 1.75e+13. What is the difference between the Imports in Hungary in 2009 and the Imports in Slovenia in 2012?
Keep it short and to the point. 1.89e+13. What is the difference between the Imports of Hungary in 2009 and the Imports of Uzbekistan in 2012?
Your answer should be compact. 1.78e+13. What is the difference between the Imports in Rwanda in 2009 and the Imports in Slovenia in 2012?
Offer a terse response. 8.54e+11. What is the difference between the Imports in Rwanda in 2009 and the Imports in Uzbekistan in 2012?
Ensure brevity in your answer.  -2.38e+11. What is the difference between the Imports in Slovenia in 2009 and the Imports in Uzbekistan in 2012?
Your answer should be very brief. -1.09e+12. What is the difference between the Imports of Hungary in 2010 and the Imports of Rwanda in 2011?
Offer a very short reply. 1.97e+13. What is the difference between the Imports in Hungary in 2010 and the Imports in Slovenia in 2011?
Provide a succinct answer. 2.08e+13. What is the difference between the Imports of Hungary in 2010 and the Imports of Uzbekistan in 2011?
Keep it short and to the point. 1.99e+13. What is the difference between the Imports in Rwanda in 2010 and the Imports in Slovenia in 2011?
Provide a succinct answer. 8.91e+11. What is the difference between the Imports of Rwanda in 2010 and the Imports of Uzbekistan in 2011?
Give a very brief answer. -2.36e+1. What is the difference between the Imports of Slovenia in 2010 and the Imports of Uzbekistan in 2011?
Your answer should be very brief. -9.16e+11. What is the difference between the Imports of Hungary in 2010 and the Imports of Rwanda in 2012?
Your answer should be compact. 1.94e+13. What is the difference between the Imports in Hungary in 2010 and the Imports in Slovenia in 2012?
Offer a terse response. 2.08e+13. What is the difference between the Imports of Hungary in 2010 and the Imports of Uzbekistan in 2012?
Keep it short and to the point. 1.97e+13. What is the difference between the Imports in Rwanda in 2010 and the Imports in Slovenia in 2012?
Your response must be concise. 8.92e+11. What is the difference between the Imports of Rwanda in 2010 and the Imports of Uzbekistan in 2012?
Make the answer very short. -2.00e+11. What is the difference between the Imports in Slovenia in 2010 and the Imports in Uzbekistan in 2012?
Your answer should be very brief. -1.09e+12. What is the difference between the Imports of Hungary in 2011 and the Imports of Rwanda in 2012?
Ensure brevity in your answer.  2.04e+13. What is the difference between the Imports in Hungary in 2011 and the Imports in Slovenia in 2012?
Your answer should be very brief. 2.17e+13. What is the difference between the Imports of Hungary in 2011 and the Imports of Uzbekistan in 2012?
Offer a terse response. 2.06e+13. What is the difference between the Imports of Rwanda in 2011 and the Imports of Slovenia in 2012?
Provide a short and direct response. 1.12e+12. What is the difference between the Imports in Rwanda in 2011 and the Imports in Uzbekistan in 2012?
Make the answer very short. 2.37e+1. What is the difference between the Imports of Slovenia in 2011 and the Imports of Uzbekistan in 2012?
Keep it short and to the point. -1.09e+12. What is the average Imports of Hungary per year?
Your answer should be very brief. 2.00e+13. What is the average Imports of Rwanda per year?
Ensure brevity in your answer.  8.57e+11. What is the average Imports of Slovenia per year?
Keep it short and to the point. 2.30e+1. What is the average Imports in Uzbekistan per year?
Your response must be concise. 6.87e+11. In the year 2005, what is the difference between the Imports in Hungary and Imports in Rwanda?
Ensure brevity in your answer.  1.53e+13. In the year 2005, what is the difference between the Imports in Hungary and Imports in Slovenia?
Your response must be concise. 1.59e+13. In the year 2005, what is the difference between the Imports of Hungary and Imports of Uzbekistan?
Your answer should be compact. 1.56e+13. In the year 2005, what is the difference between the Imports of Rwanda and Imports of Slovenia?
Provide a succinct answer. 5.24e+11. In the year 2005, what is the difference between the Imports of Rwanda and Imports of Uzbekistan?
Give a very brief answer. 2.71e+11. In the year 2005, what is the difference between the Imports of Slovenia and Imports of Uzbekistan?
Make the answer very short. -2.52e+11. In the year 2006, what is the difference between the Imports of Hungary and Imports of Rwanda?
Your answer should be compact. 1.77e+13. In the year 2006, what is the difference between the Imports in Hungary and Imports in Slovenia?
Make the answer very short. 1.83e+13. In the year 2006, what is the difference between the Imports in Hungary and Imports in Uzbekistan?
Make the answer very short. 1.80e+13. In the year 2006, what is the difference between the Imports of Rwanda and Imports of Slovenia?
Offer a terse response. 6.81e+11. In the year 2006, what is the difference between the Imports in Rwanda and Imports in Uzbekistan?
Offer a terse response. 3.48e+11. In the year 2006, what is the difference between the Imports in Slovenia and Imports in Uzbekistan?
Give a very brief answer. -3.34e+11. In the year 2007, what is the difference between the Imports in Hungary and Imports in Rwanda?
Keep it short and to the point. 2.04e+13. In the year 2007, what is the difference between the Imports of Hungary and Imports of Slovenia?
Give a very brief answer. 2.09e+13. In the year 2007, what is the difference between the Imports of Hungary and Imports of Uzbekistan?
Provide a succinct answer. 2.04e+13. In the year 2007, what is the difference between the Imports in Rwanda and Imports in Slovenia?
Offer a terse response. 4.96e+11. In the year 2007, what is the difference between the Imports of Rwanda and Imports of Uzbekistan?
Keep it short and to the point. -1.89e+1. In the year 2007, what is the difference between the Imports in Slovenia and Imports in Uzbekistan?
Your answer should be compact. -5.15e+11. In the year 2008, what is the difference between the Imports in Hungary and Imports in Rwanda?
Give a very brief answer. 2.14e+13. In the year 2008, what is the difference between the Imports of Hungary and Imports of Slovenia?
Offer a very short reply. 2.21e+13. In the year 2008, what is the difference between the Imports of Hungary and Imports of Uzbekistan?
Your response must be concise. 2.14e+13. In the year 2008, what is the difference between the Imports in Rwanda and Imports in Slovenia?
Provide a succinct answer. 7.52e+11. In the year 2008, what is the difference between the Imports in Rwanda and Imports in Uzbekistan?
Provide a short and direct response. 2.32e+1. In the year 2008, what is the difference between the Imports in Slovenia and Imports in Uzbekistan?
Provide a short and direct response. -7.29e+11. In the year 2009, what is the difference between the Imports of Hungary and Imports of Rwanda?
Keep it short and to the point. 1.80e+13. In the year 2009, what is the difference between the Imports in Hungary and Imports in Slovenia?
Provide a short and direct response. 1.89e+13. In the year 2009, what is the difference between the Imports of Hungary and Imports of Uzbekistan?
Your response must be concise. 1.81e+13. In the year 2009, what is the difference between the Imports in Rwanda and Imports in Slovenia?
Keep it short and to the point. 8.56e+11. In the year 2009, what is the difference between the Imports in Rwanda and Imports in Uzbekistan?
Keep it short and to the point. 1.02e+11. In the year 2009, what is the difference between the Imports in Slovenia and Imports in Uzbekistan?
Give a very brief answer. -7.54e+11. In the year 2010, what is the difference between the Imports in Hungary and Imports in Rwanda?
Offer a terse response. 1.99e+13. In the year 2010, what is the difference between the Imports of Hungary and Imports of Slovenia?
Provide a short and direct response. 2.08e+13. In the year 2010, what is the difference between the Imports in Hungary and Imports in Uzbekistan?
Give a very brief answer. 2.01e+13. In the year 2010, what is the difference between the Imports in Rwanda and Imports in Slovenia?
Provide a short and direct response. 8.92e+11. In the year 2010, what is the difference between the Imports in Rwanda and Imports in Uzbekistan?
Give a very brief answer. 1.72e+11. In the year 2010, what is the difference between the Imports in Slovenia and Imports in Uzbekistan?
Ensure brevity in your answer.  -7.20e+11. In the year 2011, what is the difference between the Imports in Hungary and Imports in Rwanda?
Ensure brevity in your answer.  2.06e+13. In the year 2011, what is the difference between the Imports of Hungary and Imports of Slovenia?
Give a very brief answer. 2.17e+13. In the year 2011, what is the difference between the Imports of Hungary and Imports of Uzbekistan?
Provide a succinct answer. 2.08e+13. In the year 2011, what is the difference between the Imports in Rwanda and Imports in Slovenia?
Your answer should be very brief. 1.12e+12. In the year 2011, what is the difference between the Imports in Rwanda and Imports in Uzbekistan?
Your answer should be compact. 2.00e+11. In the year 2011, what is the difference between the Imports of Slovenia and Imports of Uzbekistan?
Your response must be concise. -9.15e+11. In the year 2012, what is the difference between the Imports of Hungary and Imports of Rwanda?
Offer a very short reply. 1.96e+13. In the year 2012, what is the difference between the Imports of Hungary and Imports of Slovenia?
Ensure brevity in your answer.  2.10e+13. In the year 2012, what is the difference between the Imports in Hungary and Imports in Uzbekistan?
Your response must be concise. 1.99e+13. In the year 2012, what is the difference between the Imports of Rwanda and Imports of Slovenia?
Offer a very short reply. 1.36e+12. In the year 2012, what is the difference between the Imports in Rwanda and Imports in Uzbekistan?
Your answer should be compact. 2.67e+11. In the year 2012, what is the difference between the Imports of Slovenia and Imports of Uzbekistan?
Your response must be concise. -1.09e+12. What is the ratio of the Imports of Hungary in 2005 to that in 2006?
Give a very brief answer. 0.87. What is the ratio of the Imports in Rwanda in 2005 to that in 2006?
Provide a short and direct response. 0.77. What is the ratio of the Imports in Slovenia in 2005 to that in 2006?
Ensure brevity in your answer.  0.89. What is the ratio of the Imports in Uzbekistan in 2005 to that in 2006?
Provide a succinct answer. 0.76. What is the ratio of the Imports of Hungary in 2005 to that in 2007?
Provide a short and direct response. 0.76. What is the ratio of the Imports of Rwanda in 2005 to that in 2007?
Offer a very short reply. 1.04. What is the ratio of the Imports of Slovenia in 2005 to that in 2007?
Make the answer very short. 0.76. What is the ratio of the Imports in Uzbekistan in 2005 to that in 2007?
Provide a succinct answer. 0.5. What is the ratio of the Imports of Hungary in 2005 to that in 2008?
Keep it short and to the point. 0.72. What is the ratio of the Imports of Rwanda in 2005 to that in 2008?
Your answer should be compact. 0.7. What is the ratio of the Imports of Slovenia in 2005 to that in 2008?
Provide a short and direct response. 0.73. What is the ratio of the Imports of Uzbekistan in 2005 to that in 2008?
Ensure brevity in your answer.  0.36. What is the ratio of the Imports of Hungary in 2005 to that in 2009?
Provide a short and direct response. 0.84. What is the ratio of the Imports of Rwanda in 2005 to that in 2009?
Offer a terse response. 0.62. What is the ratio of the Imports in Slovenia in 2005 to that in 2009?
Give a very brief answer. 0.9. What is the ratio of the Imports in Uzbekistan in 2005 to that in 2009?
Your answer should be compact. 0.35. What is the ratio of the Imports of Hungary in 2005 to that in 2010?
Your answer should be very brief. 0.76. What is the ratio of the Imports in Rwanda in 2005 to that in 2010?
Offer a very short reply. 0.59. What is the ratio of the Imports in Slovenia in 2005 to that in 2010?
Make the answer very short. 0.85. What is the ratio of the Imports in Uzbekistan in 2005 to that in 2010?
Your answer should be very brief. 0.37. What is the ratio of the Imports of Hungary in 2005 to that in 2011?
Your response must be concise. 0.73. What is the ratio of the Imports of Rwanda in 2005 to that in 2011?
Keep it short and to the point. 0.48. What is the ratio of the Imports in Slovenia in 2005 to that in 2011?
Ensure brevity in your answer.  0.81. What is the ratio of the Imports in Uzbekistan in 2005 to that in 2011?
Your response must be concise. 0.29. What is the ratio of the Imports of Hungary in 2005 to that in 2012?
Your answer should be very brief. 0.76. What is the ratio of the Imports in Rwanda in 2005 to that in 2012?
Provide a short and direct response. 0.39. What is the ratio of the Imports of Slovenia in 2005 to that in 2012?
Your answer should be compact. 0.84. What is the ratio of the Imports in Uzbekistan in 2005 to that in 2012?
Offer a terse response. 0.24. What is the ratio of the Imports of Hungary in 2006 to that in 2007?
Offer a very short reply. 0.88. What is the ratio of the Imports in Rwanda in 2006 to that in 2007?
Your answer should be very brief. 1.35. What is the ratio of the Imports in Slovenia in 2006 to that in 2007?
Keep it short and to the point. 0.86. What is the ratio of the Imports of Uzbekistan in 2006 to that in 2007?
Your answer should be compact. 0.66. What is the ratio of the Imports in Hungary in 2006 to that in 2008?
Offer a terse response. 0.83. What is the ratio of the Imports of Rwanda in 2006 to that in 2008?
Keep it short and to the point. 0.9. What is the ratio of the Imports in Slovenia in 2006 to that in 2008?
Provide a succinct answer. 0.82. What is the ratio of the Imports of Uzbekistan in 2006 to that in 2008?
Your answer should be very brief. 0.47. What is the ratio of the Imports in Hungary in 2006 to that in 2009?
Give a very brief answer. 0.97. What is the ratio of the Imports in Rwanda in 2006 to that in 2009?
Provide a succinct answer. 0.8. What is the ratio of the Imports of Slovenia in 2006 to that in 2009?
Give a very brief answer. 1.02. What is the ratio of the Imports in Uzbekistan in 2006 to that in 2009?
Give a very brief answer. 0.46. What is the ratio of the Imports of Hungary in 2006 to that in 2010?
Provide a succinct answer. 0.88. What is the ratio of the Imports in Rwanda in 2006 to that in 2010?
Give a very brief answer. 0.77. What is the ratio of the Imports of Slovenia in 2006 to that in 2010?
Your answer should be very brief. 0.95. What is the ratio of the Imports in Uzbekistan in 2006 to that in 2010?
Ensure brevity in your answer.  0.48. What is the ratio of the Imports of Hungary in 2006 to that in 2011?
Keep it short and to the point. 0.84. What is the ratio of the Imports in Rwanda in 2006 to that in 2011?
Your answer should be compact. 0.62. What is the ratio of the Imports in Slovenia in 2006 to that in 2011?
Provide a short and direct response. 0.91. What is the ratio of the Imports of Uzbekistan in 2006 to that in 2011?
Keep it short and to the point. 0.38. What is the ratio of the Imports in Hungary in 2006 to that in 2012?
Offer a very short reply. 0.87. What is the ratio of the Imports in Rwanda in 2006 to that in 2012?
Your answer should be very brief. 0.51. What is the ratio of the Imports in Slovenia in 2006 to that in 2012?
Make the answer very short. 0.94. What is the ratio of the Imports of Uzbekistan in 2006 to that in 2012?
Your response must be concise. 0.32. What is the ratio of the Imports of Hungary in 2007 to that in 2008?
Your answer should be very brief. 0.94. What is the ratio of the Imports in Rwanda in 2007 to that in 2008?
Give a very brief answer. 0.67. What is the ratio of the Imports in Slovenia in 2007 to that in 2008?
Give a very brief answer. 0.96. What is the ratio of the Imports of Uzbekistan in 2007 to that in 2008?
Make the answer very short. 0.72. What is the ratio of the Imports of Hungary in 2007 to that in 2009?
Make the answer very short. 1.11. What is the ratio of the Imports of Rwanda in 2007 to that in 2009?
Give a very brief answer. 0.59. What is the ratio of the Imports in Slovenia in 2007 to that in 2009?
Your answer should be very brief. 1.19. What is the ratio of the Imports of Uzbekistan in 2007 to that in 2009?
Provide a succinct answer. 0.7. What is the ratio of the Imports of Hungary in 2007 to that in 2010?
Your answer should be very brief. 1. What is the ratio of the Imports in Rwanda in 2007 to that in 2010?
Provide a succinct answer. 0.57. What is the ratio of the Imports of Slovenia in 2007 to that in 2010?
Your answer should be very brief. 1.11. What is the ratio of the Imports of Uzbekistan in 2007 to that in 2010?
Ensure brevity in your answer.  0.73. What is the ratio of the Imports in Hungary in 2007 to that in 2011?
Provide a short and direct response. 0.96. What is the ratio of the Imports of Rwanda in 2007 to that in 2011?
Provide a short and direct response. 0.46. What is the ratio of the Imports in Slovenia in 2007 to that in 2011?
Ensure brevity in your answer.  1.06. What is the ratio of the Imports of Uzbekistan in 2007 to that in 2011?
Offer a very short reply. 0.58. What is the ratio of the Imports in Rwanda in 2007 to that in 2012?
Make the answer very short. 0.38. What is the ratio of the Imports of Slovenia in 2007 to that in 2012?
Your answer should be compact. 1.1. What is the ratio of the Imports of Uzbekistan in 2007 to that in 2012?
Provide a short and direct response. 0.48. What is the ratio of the Imports in Hungary in 2008 to that in 2009?
Ensure brevity in your answer.  1.17. What is the ratio of the Imports in Rwanda in 2008 to that in 2009?
Your answer should be very brief. 0.89. What is the ratio of the Imports in Slovenia in 2008 to that in 2009?
Your answer should be very brief. 1.23. What is the ratio of the Imports in Uzbekistan in 2008 to that in 2009?
Offer a terse response. 0.97. What is the ratio of the Imports of Hungary in 2008 to that in 2010?
Your answer should be compact. 1.06. What is the ratio of the Imports of Rwanda in 2008 to that in 2010?
Offer a terse response. 0.85. What is the ratio of the Imports in Slovenia in 2008 to that in 2010?
Give a very brief answer. 1.15. What is the ratio of the Imports in Uzbekistan in 2008 to that in 2010?
Give a very brief answer. 1.02. What is the ratio of the Imports in Hungary in 2008 to that in 2011?
Offer a very short reply. 1.02. What is the ratio of the Imports in Rwanda in 2008 to that in 2011?
Give a very brief answer. 0.68. What is the ratio of the Imports in Slovenia in 2008 to that in 2011?
Keep it short and to the point. 1.1. What is the ratio of the Imports of Uzbekistan in 2008 to that in 2011?
Keep it short and to the point. 0.8. What is the ratio of the Imports in Hungary in 2008 to that in 2012?
Your answer should be very brief. 1.06. What is the ratio of the Imports in Rwanda in 2008 to that in 2012?
Your response must be concise. 0.56. What is the ratio of the Imports of Slovenia in 2008 to that in 2012?
Give a very brief answer. 1.14. What is the ratio of the Imports in Uzbekistan in 2008 to that in 2012?
Your response must be concise. 0.68. What is the ratio of the Imports in Hungary in 2009 to that in 2010?
Offer a very short reply. 0.91. What is the ratio of the Imports in Rwanda in 2009 to that in 2010?
Give a very brief answer. 0.96. What is the ratio of the Imports in Slovenia in 2009 to that in 2010?
Give a very brief answer. 0.94. What is the ratio of the Imports in Uzbekistan in 2009 to that in 2010?
Make the answer very short. 1.04. What is the ratio of the Imports in Hungary in 2009 to that in 2011?
Your answer should be compact. 0.87. What is the ratio of the Imports in Rwanda in 2009 to that in 2011?
Make the answer very short. 0.77. What is the ratio of the Imports of Slovenia in 2009 to that in 2011?
Keep it short and to the point. 0.89. What is the ratio of the Imports in Uzbekistan in 2009 to that in 2011?
Provide a short and direct response. 0.83. What is the ratio of the Imports in Hungary in 2009 to that in 2012?
Provide a succinct answer. 0.9. What is the ratio of the Imports of Rwanda in 2009 to that in 2012?
Your response must be concise. 0.63. What is the ratio of the Imports in Slovenia in 2009 to that in 2012?
Provide a succinct answer. 0.93. What is the ratio of the Imports in Uzbekistan in 2009 to that in 2012?
Make the answer very short. 0.69. What is the ratio of the Imports of Hungary in 2010 to that in 2011?
Make the answer very short. 0.96. What is the ratio of the Imports in Rwanda in 2010 to that in 2011?
Your answer should be compact. 0.8. What is the ratio of the Imports of Slovenia in 2010 to that in 2011?
Provide a short and direct response. 0.95. What is the ratio of the Imports in Uzbekistan in 2010 to that in 2011?
Keep it short and to the point. 0.79. What is the ratio of the Imports in Rwanda in 2010 to that in 2012?
Your answer should be very brief. 0.66. What is the ratio of the Imports in Slovenia in 2010 to that in 2012?
Provide a succinct answer. 0.99. What is the ratio of the Imports in Uzbekistan in 2010 to that in 2012?
Make the answer very short. 0.67. What is the ratio of the Imports of Hungary in 2011 to that in 2012?
Your answer should be compact. 1.04. What is the ratio of the Imports of Rwanda in 2011 to that in 2012?
Your answer should be very brief. 0.82. What is the ratio of the Imports in Slovenia in 2011 to that in 2012?
Offer a terse response. 1.04. What is the ratio of the Imports of Uzbekistan in 2011 to that in 2012?
Offer a terse response. 0.84. What is the difference between the highest and the second highest Imports in Hungary?
Ensure brevity in your answer.  4.21e+11. What is the difference between the highest and the second highest Imports in Rwanda?
Offer a terse response. 2.43e+11. What is the difference between the highest and the second highest Imports of Slovenia?
Your answer should be compact. 9.74e+08. What is the difference between the highest and the second highest Imports in Uzbekistan?
Offer a terse response. 1.77e+11. What is the difference between the highest and the lowest Imports in Hungary?
Your answer should be very brief. 6.28e+12. What is the difference between the highest and the lowest Imports in Rwanda?
Ensure brevity in your answer.  8.61e+11. What is the difference between the highest and the lowest Imports of Slovenia?
Your answer should be very brief. 7.00e+09. What is the difference between the highest and the lowest Imports of Uzbekistan?
Make the answer very short. 8.44e+11. 